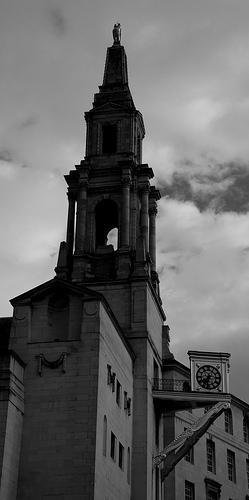Express the central subject in the image and what stands atop it. The central subject is an old tower with a clock, and there is a statue at the top of the tower. Please provide a general description of the scene in the image. The scene shows a tall brick tower with a clock, statue, and various architectural features against the sky. List the visible components of the clock on the building and their colors. The clock has a white face, black hands, and black Roman numerals. Briefly describe the most noticeable elements in the image. The image features a tall tower with a clock, open arches, and a statue at the top, surrounded by columns. Mention the primary object in the picture and its basic characteristics. A clock with a white face and black Roman numerals is located on the side of a tall, old brick tower. What architectural details can be observed on the building in the image? The building has a clock, columns, open arches, parapets, and windows with arch-shaped design. Mention the main focus of the image, and include the colors of the photo. The main focus is the clock on the brick tower, and the photo is black and white. Describe the building's most prominent feature and its construction material. The most prominent feature is the clock on the side of the building, which is made of brick. Briefly state the major attraction of the building and the style of the photograph. The major attraction is the clock tower, and the photograph is in black and white style. Describe the most visible components of the tower and the fencing in the picture. The tower has a clock, columns, open arches, and a statue at the top, with a black fence on a platform. 